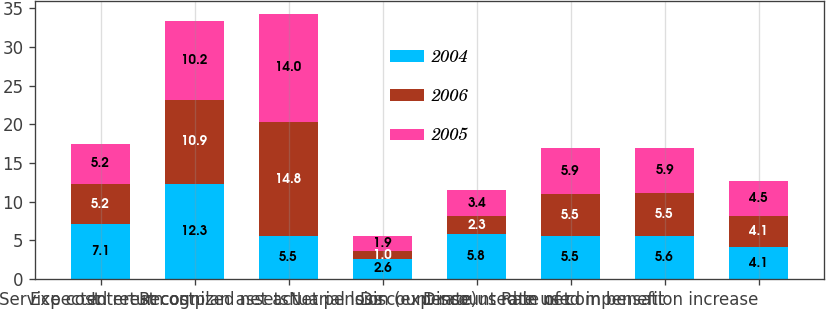Convert chart to OTSL. <chart><loc_0><loc_0><loc_500><loc_500><stacked_bar_chart><ecel><fcel>Service cost<fcel>Interest cost<fcel>Expected return on plan assets<fcel>Recognized net actuarial loss<fcel>Net pension (expense)<fcel>Discount rate used in net<fcel>Discount rate used in benefit<fcel>Rate of compensation increase<nl><fcel>2004<fcel>7.1<fcel>12.3<fcel>5.5<fcel>2.6<fcel>5.8<fcel>5.5<fcel>5.6<fcel>4.1<nl><fcel>2006<fcel>5.2<fcel>10.9<fcel>14.8<fcel>1<fcel>2.3<fcel>5.5<fcel>5.5<fcel>4.1<nl><fcel>2005<fcel>5.2<fcel>10.2<fcel>14<fcel>1.9<fcel>3.4<fcel>5.9<fcel>5.9<fcel>4.5<nl></chart> 